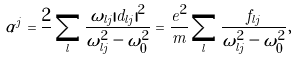<formula> <loc_0><loc_0><loc_500><loc_500>\alpha ^ { j } = \frac { 2 } { } \sum _ { l } \frac { \omega _ { l j } | d _ { l j } | ^ { 2 } } { \omega ^ { 2 } _ { l j } - \omega ^ { 2 } _ { 0 } } = \frac { e ^ { 2 } } { m } \sum _ { l } \frac { f _ { l j } } { \omega ^ { 2 } _ { l j } - \omega ^ { 2 } _ { 0 } } ,</formula> 